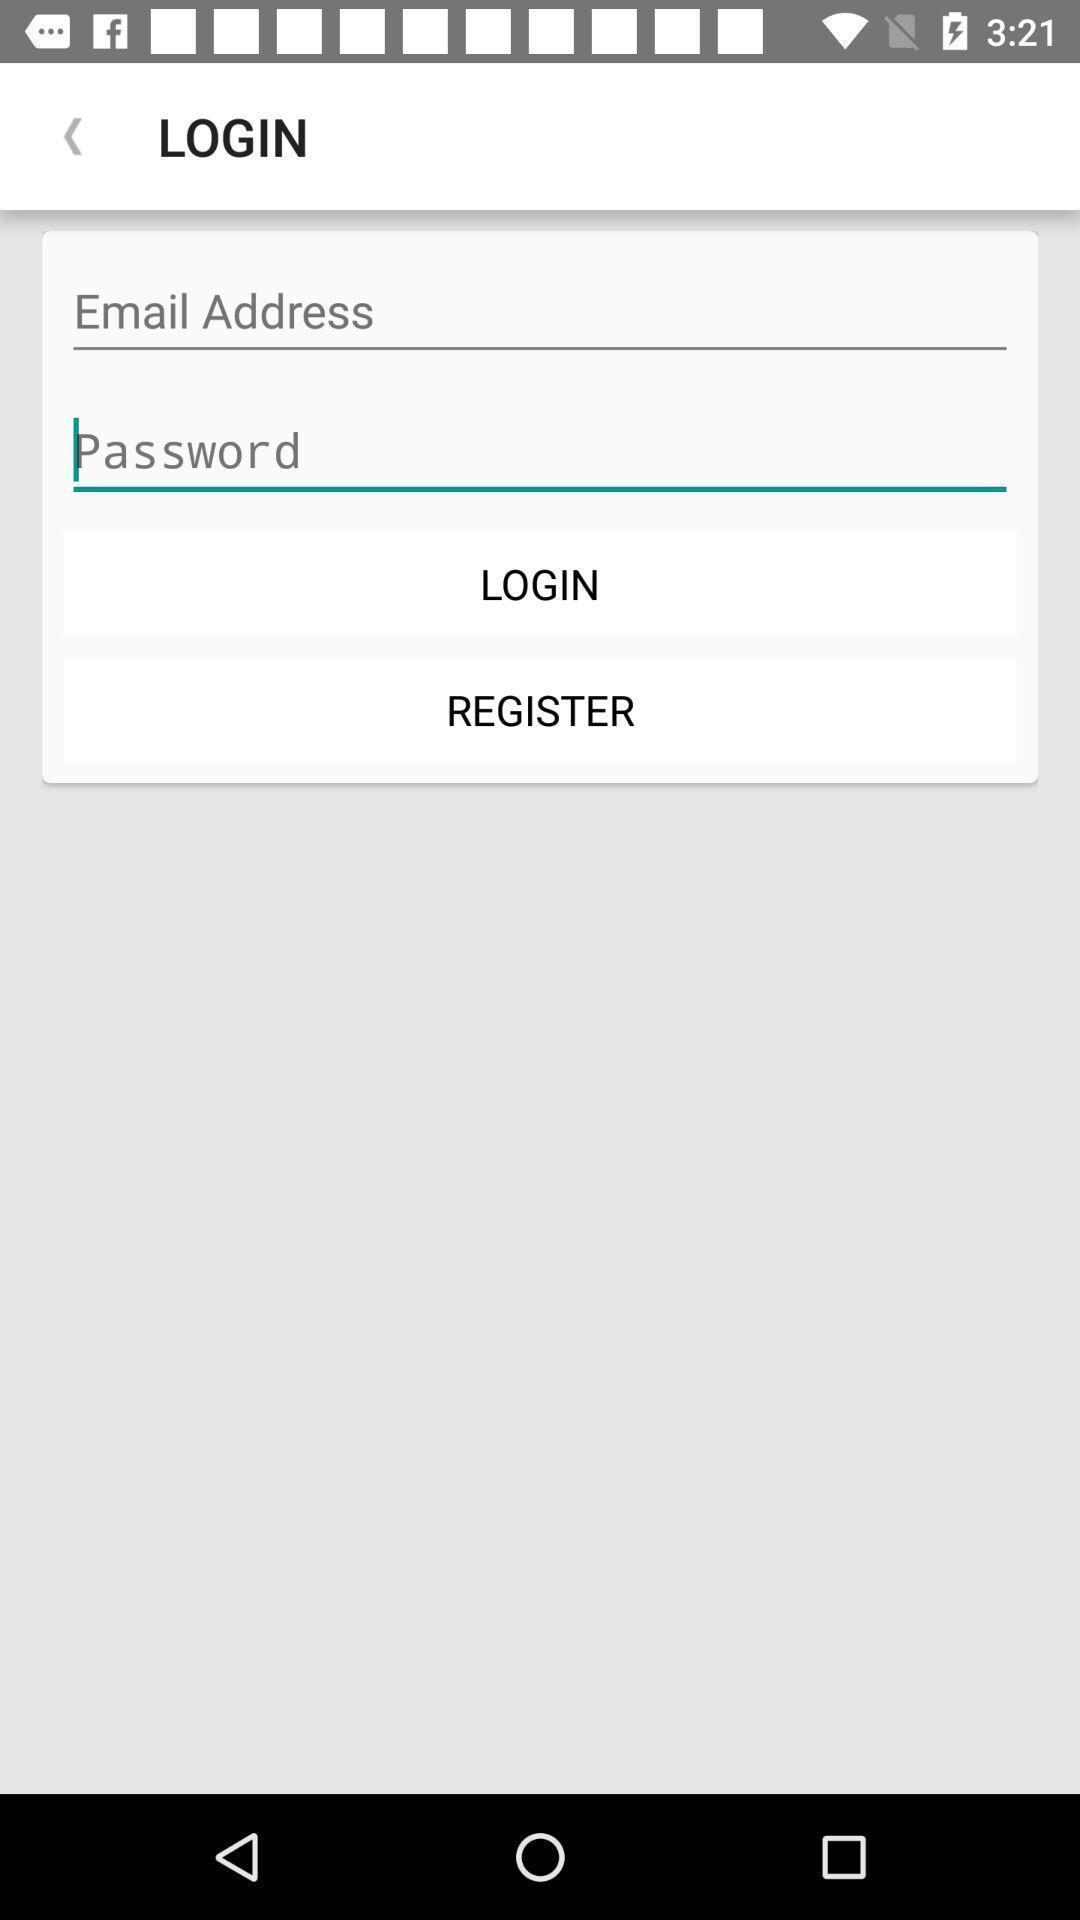Summarize the information in this screenshot. Page displaying login information with other options to continue. 